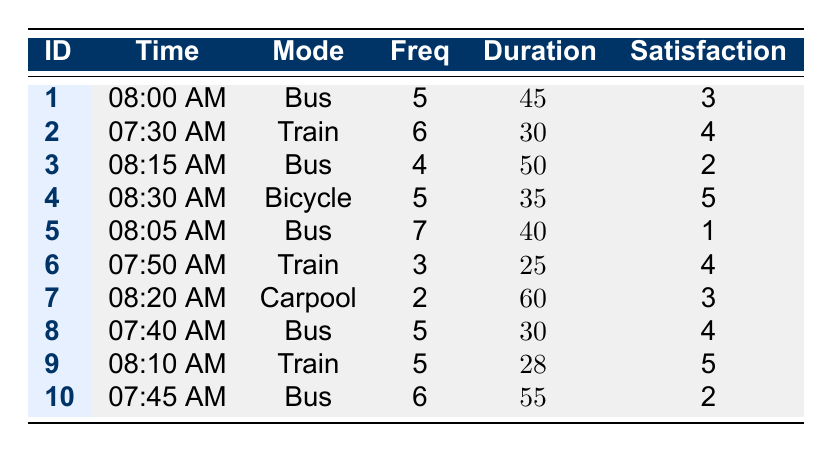What is the commuting time of commuter ID 4? The table shows that commuter ID 4 has a commuting time listed as "08:30 AM."
Answer: 08:30 AM How many passengers use the Bus as their transport mode? By counting the entries in the table, there are 5 instances where the transport mode is listed as Bus (IDs 1, 3, 5, 8, and 10).
Answer: 5 What is the average daily frequency of commuters using the Train? The daily frequencies for the Train mode are 6 (ID 2), 3 (ID 6), and 5 (ID 9). To find the average, sum these values: 6 + 3 + 5 = 14 and then divide by 3 (the number of Train commuters), giving 14/3 ≈ 4.67.
Answer: 4.67 Did commuter ID 5 express a high satisfaction level? Commuter ID 5 has a satisfaction level of 1, which is low and indicates dissatisfaction.
Answer: No Which transport mode has the highest satisfaction level? The table indicates that the Bicycle mode (ID 4) has the highest satisfaction level of 5, compared to the others.
Answer: Bicycle What is the total average commute duration for all commuters using the Bus? The average commutes for Bus users are 45 minutes (ID 1), 50 minutes (ID 3), 40 minutes (ID 5), 30 minutes (ID 8), and 55 minutes (ID 10). Summing these gives 220 minutes, then averaging (220/5) gives 44 minutes.
Answer: 44 minutes How many commuters rated their satisfaction level at 4 or higher? The commuters with satisfaction levels of 4 or above are IDs 2, 4, 6, 8, and 9. Counting these gives a total of 5 commuters.
Answer: 5 What is the difference in average commute duration between the Bus and Train users? For the three Train users: 30 (ID 2), 25 (ID 6), and 28 (ID 9) average to 27.67 minutes. For Bus users: 45 (ID 1), 50 (ID 3), 40 (ID 5), 30 (ID 8), and 55 (ID 10) average to 44 minutes. The difference is 44 - 27.67 = 16.33 minutes.
Answer: 16.33 minutes Which commuting time has the highest daily frequency? Review the daily frequencies for commuting times: 5 (IDs 1, 4, 8), 6 (IDs 2, 10), 7 (ID 5). ID 5 at 8:05 AM has the highest daily frequency of 7.
Answer: 8:05 AM What is the lowest satisfaction level recorded and which commuter does it belong to? The lowest satisfaction level recorded is 1, which belongs to commuter ID 5.
Answer: ID 5 